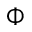Convert formula to latex. <formula><loc_0><loc_0><loc_500><loc_500>\Phi</formula> 